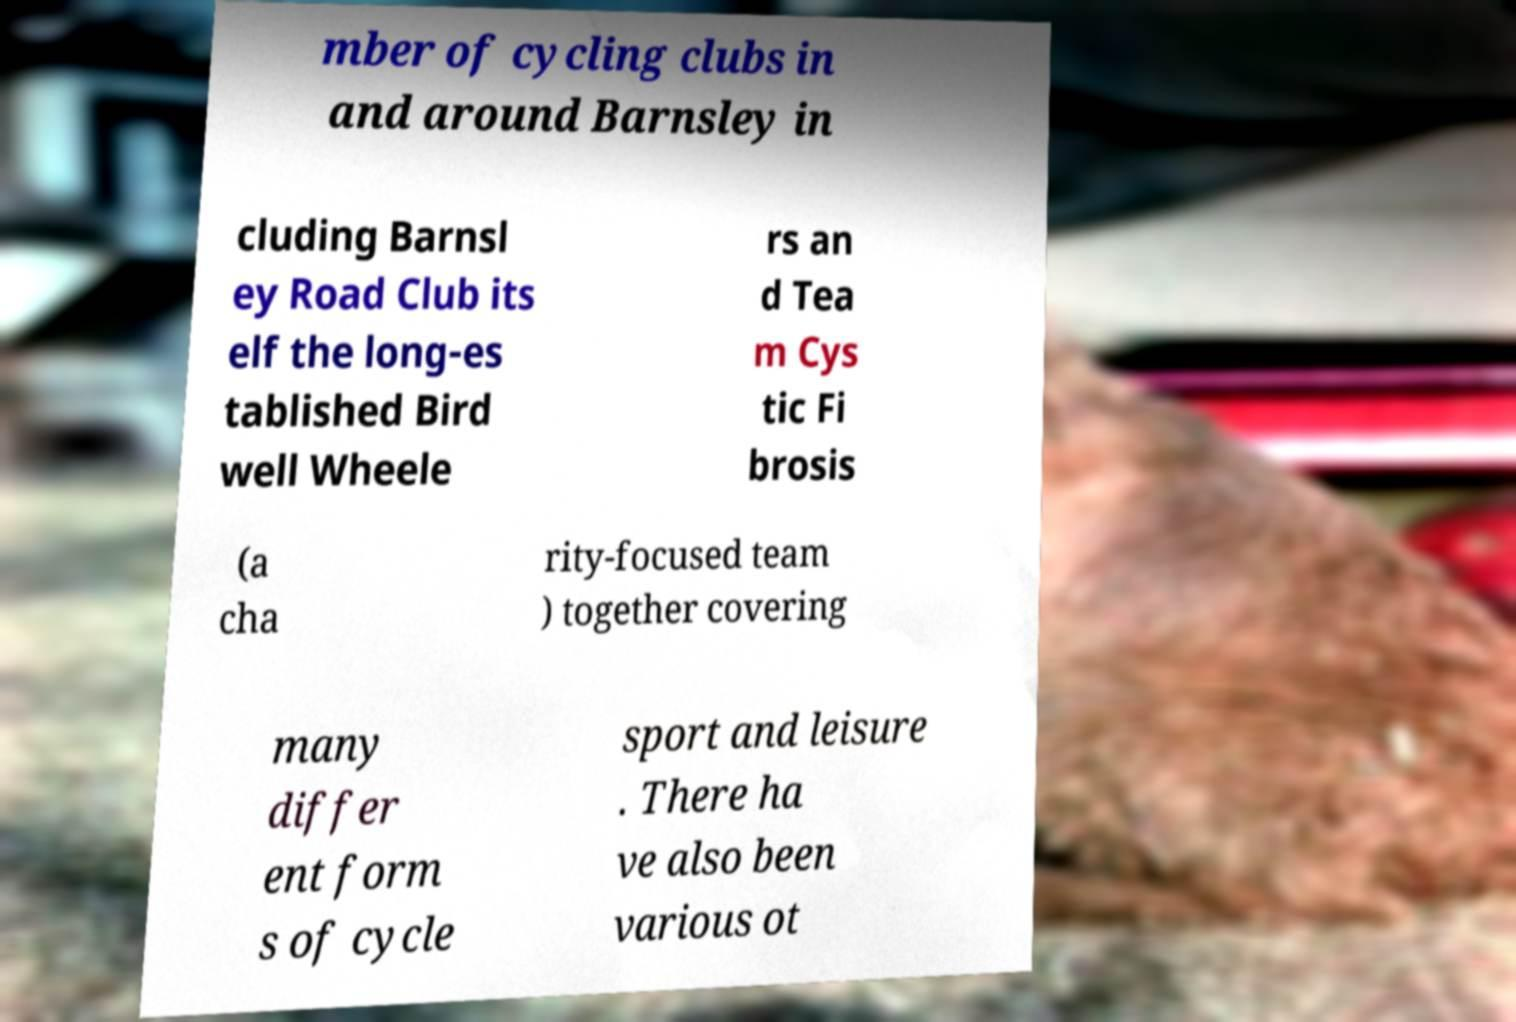Please read and relay the text visible in this image. What does it say? mber of cycling clubs in and around Barnsley in cluding Barnsl ey Road Club its elf the long-es tablished Bird well Wheele rs an d Tea m Cys tic Fi brosis (a cha rity-focused team ) together covering many differ ent form s of cycle sport and leisure . There ha ve also been various ot 